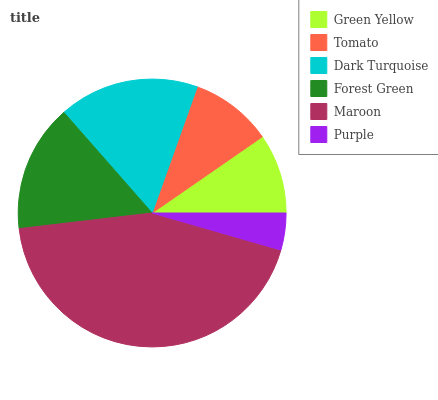Is Purple the minimum?
Answer yes or no. Yes. Is Maroon the maximum?
Answer yes or no. Yes. Is Tomato the minimum?
Answer yes or no. No. Is Tomato the maximum?
Answer yes or no. No. Is Tomato greater than Green Yellow?
Answer yes or no. Yes. Is Green Yellow less than Tomato?
Answer yes or no. Yes. Is Green Yellow greater than Tomato?
Answer yes or no. No. Is Tomato less than Green Yellow?
Answer yes or no. No. Is Forest Green the high median?
Answer yes or no. Yes. Is Tomato the low median?
Answer yes or no. Yes. Is Purple the high median?
Answer yes or no. No. Is Green Yellow the low median?
Answer yes or no. No. 